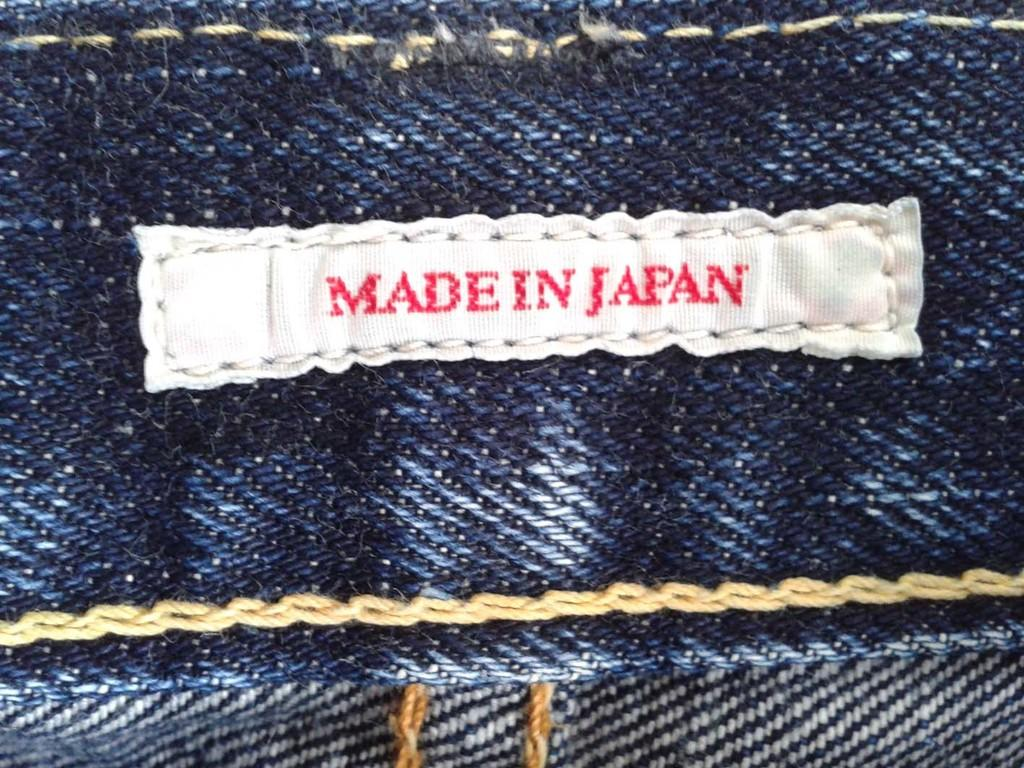What type of objects can be seen in the image? There are clothes in the image. Can you describe a specific type of cloth in the image? There is a white cloth in the image. What is unique about the white cloth? There is text on the white cloth. What type of silverware is visible on the sheet in the image? There is no sheet or silverware present in the image. 